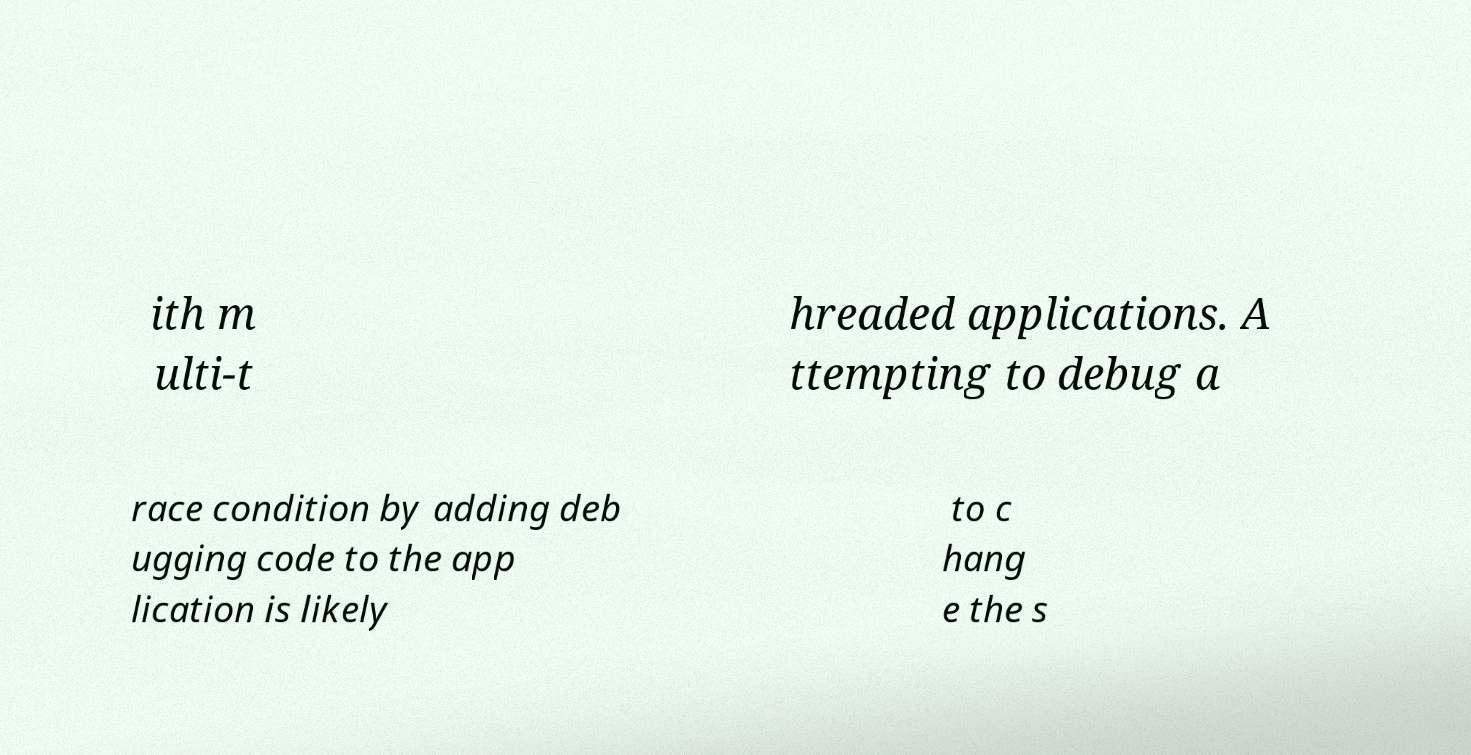Can you accurately transcribe the text from the provided image for me? ith m ulti-t hreaded applications. A ttempting to debug a race condition by adding deb ugging code to the app lication is likely to c hang e the s 